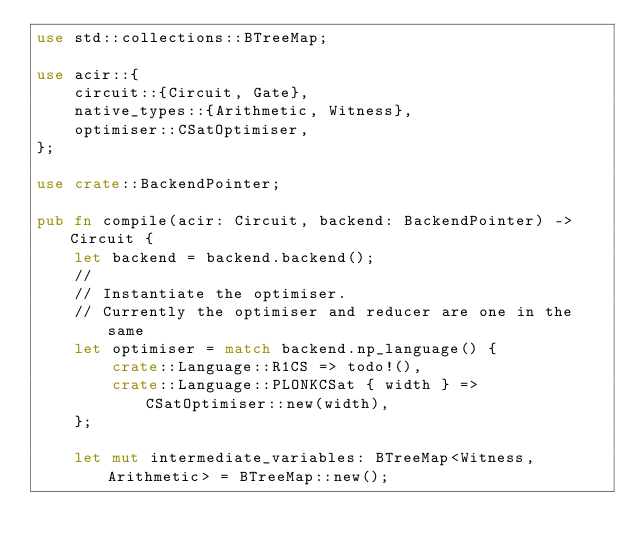Convert code to text. <code><loc_0><loc_0><loc_500><loc_500><_Rust_>use std::collections::BTreeMap;

use acir::{
    circuit::{Circuit, Gate},
    native_types::{Arithmetic, Witness},
    optimiser::CSatOptimiser,
};

use crate::BackendPointer;

pub fn compile(acir: Circuit, backend: BackendPointer) -> Circuit {
    let backend = backend.backend();
    //
    // Instantiate the optimiser.
    // Currently the optimiser and reducer are one in the same
    let optimiser = match backend.np_language() {
        crate::Language::R1CS => todo!(),
        crate::Language::PLONKCSat { width } => CSatOptimiser::new(width),
    };

    let mut intermediate_variables: BTreeMap<Witness, Arithmetic> = BTreeMap::new();
</code> 